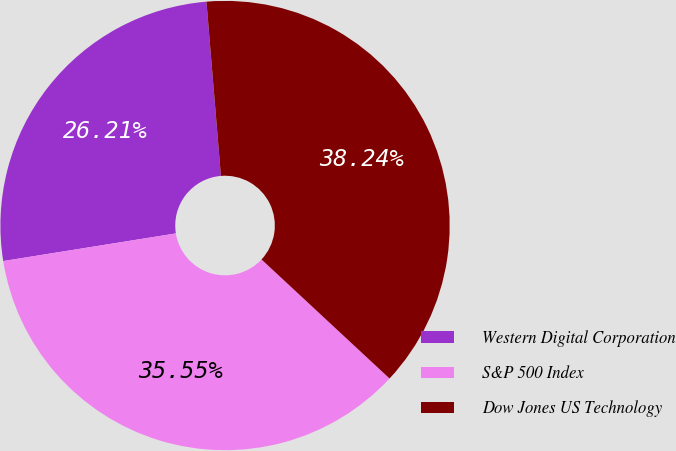<chart> <loc_0><loc_0><loc_500><loc_500><pie_chart><fcel>Western Digital Corporation<fcel>S&P 500 Index<fcel>Dow Jones US Technology<nl><fcel>26.21%<fcel>35.55%<fcel>38.24%<nl></chart> 